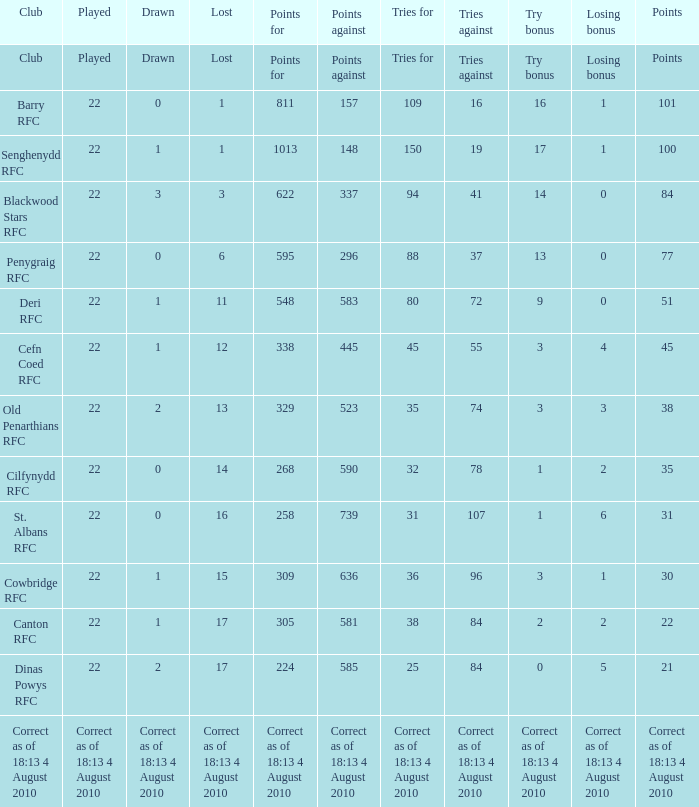When there are 84 games played against and 2 drawn, what is the total count of played games? 22.0. 